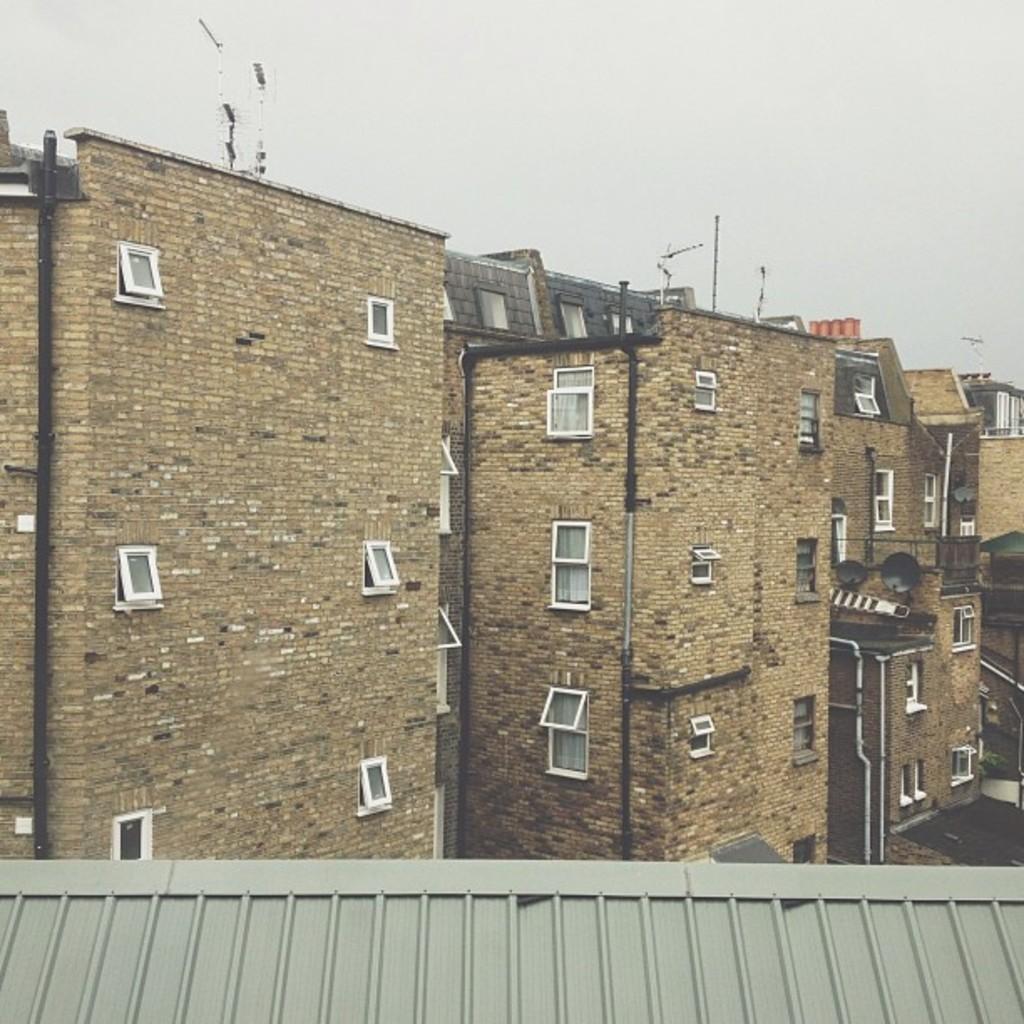Can you describe this image briefly? In this picture I can see number of buildings and on the top of this picture I can see the sky. On the bottom of this picture I can see the roof of a building. 